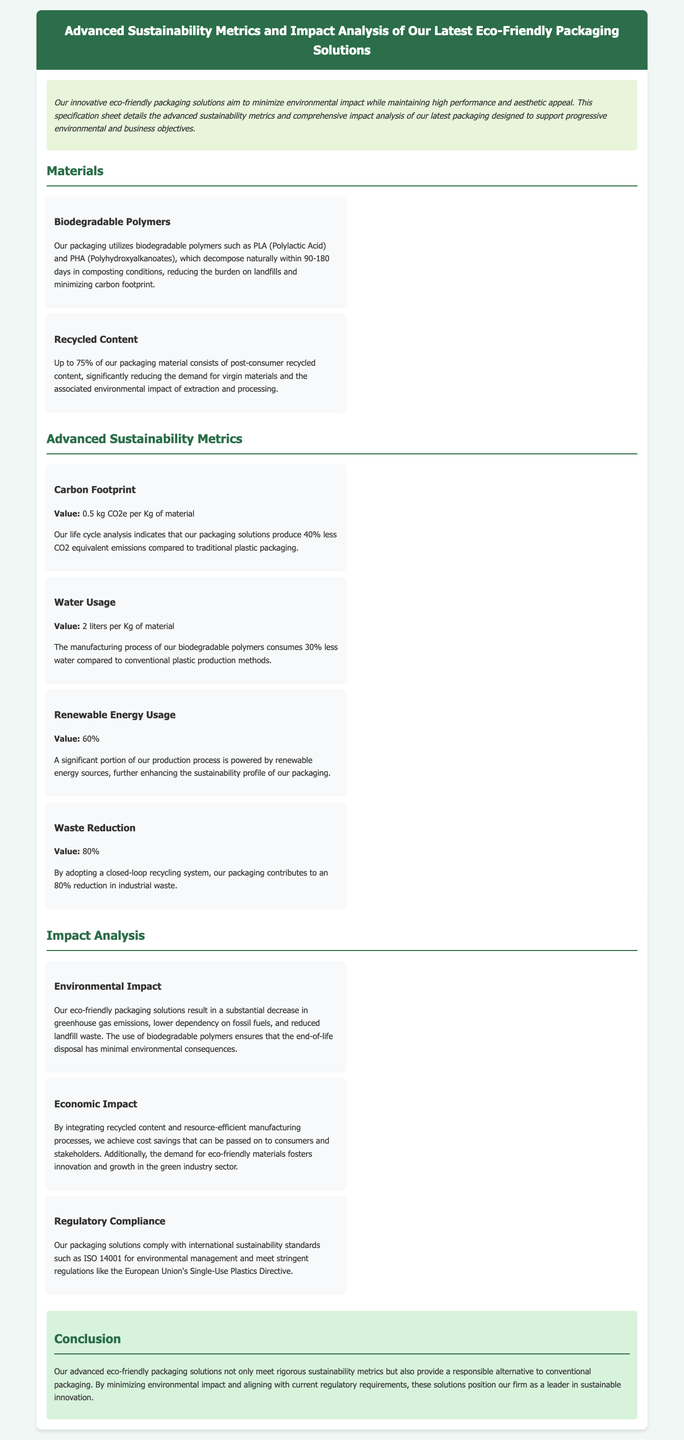What are the biodegradable polymers used in the packaging? The document specifies that the packaging utilizes PLA (Polylactic Acid) and PHA (Polyhydroxyalkanoates).
Answer: PLA and PHA What is the carbon footprint of the packaging? According to the advanced sustainability metrics, the carbon footprint is 0.5 kg CO2e per Kg of material.
Answer: 0.5 kg CO2e per Kg What percentage of the packaging material consists of post-consumer recycled content? The document states that up to 75% of the material consists of post-consumer recycled content.
Answer: 75% What is the water usage during the manufacturing process? The water usage metric indicates that it is 2 liters per Kg of material.
Answer: 2 liters per Kg How much waste reduction does the packaging achieve? The waste reduction value provided in the document is 80%.
Answer: 80% What is the economic impact of integrating recycled content? The document mentions that integrating recycled content achieves cost savings that can be passed on to consumers and stakeholders.
Answer: Cost savings Which international sustainability standard does the packaging comply with? The packaging solutions comply with ISO 14001 for environmental management.
Answer: ISO 14001 What is the impact on greenhouse gas emissions? The document indicates a substantial decrease in greenhouse gas emissions as an environmental impact.
Answer: Substantial decrease What is the primary goal of the eco-friendly packaging solutions? The executive summary outlines that the primary goal is to minimize environmental impact while maintaining high performance.
Answer: Minimize environmental impact 